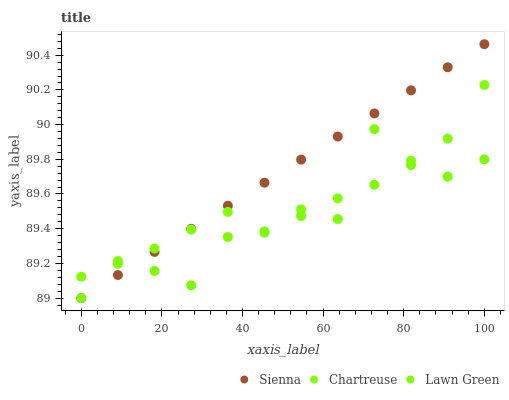Does Lawn Green have the minimum area under the curve?
Answer yes or no. Yes. Does Sienna have the maximum area under the curve?
Answer yes or no. Yes. Does Chartreuse have the minimum area under the curve?
Answer yes or no. No. Does Chartreuse have the maximum area under the curve?
Answer yes or no. No. Is Sienna the smoothest?
Answer yes or no. Yes. Is Chartreuse the roughest?
Answer yes or no. Yes. Is Lawn Green the smoothest?
Answer yes or no. No. Is Lawn Green the roughest?
Answer yes or no. No. Does Sienna have the lowest value?
Answer yes or no. Yes. Does Chartreuse have the lowest value?
Answer yes or no. No. Does Sienna have the highest value?
Answer yes or no. Yes. Does Chartreuse have the highest value?
Answer yes or no. No. Does Chartreuse intersect Lawn Green?
Answer yes or no. Yes. Is Chartreuse less than Lawn Green?
Answer yes or no. No. Is Chartreuse greater than Lawn Green?
Answer yes or no. No. 